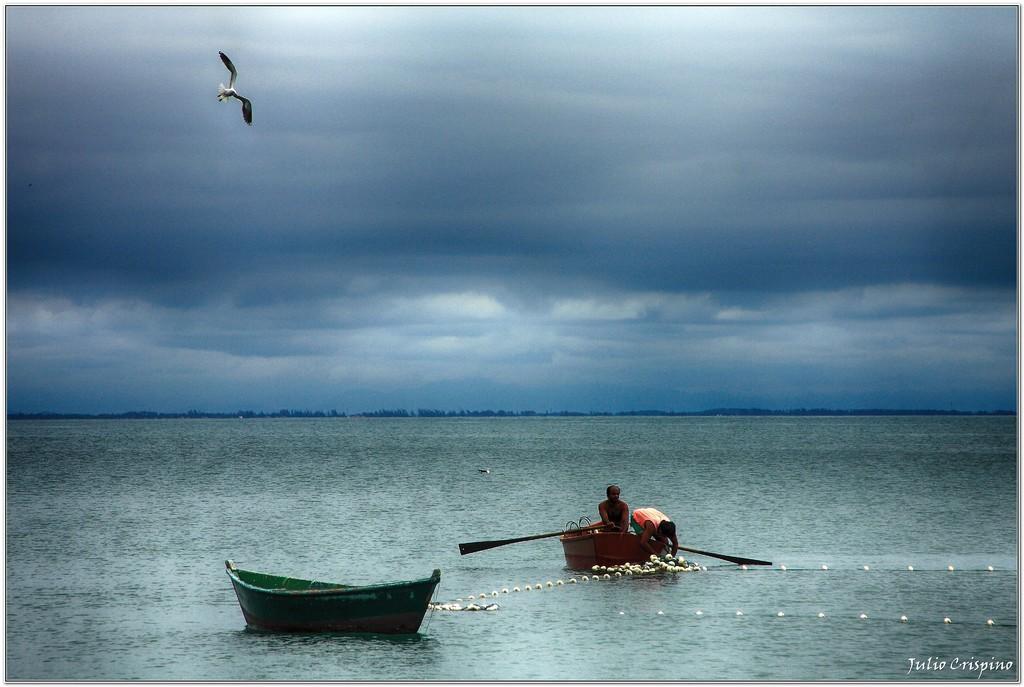Could you give a brief overview of what you see in this image? In this image there are two people sitting on the boat and they are holding the paddles. In front of the boat there is another boat in the water. There are few objects in the water. There is a bird in the air. In the background of the image there are trees and sky. There is some text at the bottom of the image. 